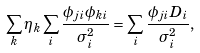<formula> <loc_0><loc_0><loc_500><loc_500>\sum _ { k } \eta _ { k } \sum _ { i } \frac { \phi _ { j i } \phi _ { k i } } { \sigma _ { i } ^ { 2 } } = \sum _ { i } \frac { \phi _ { j i } D _ { i } } { \sigma _ { i } ^ { 2 } } ,</formula> 